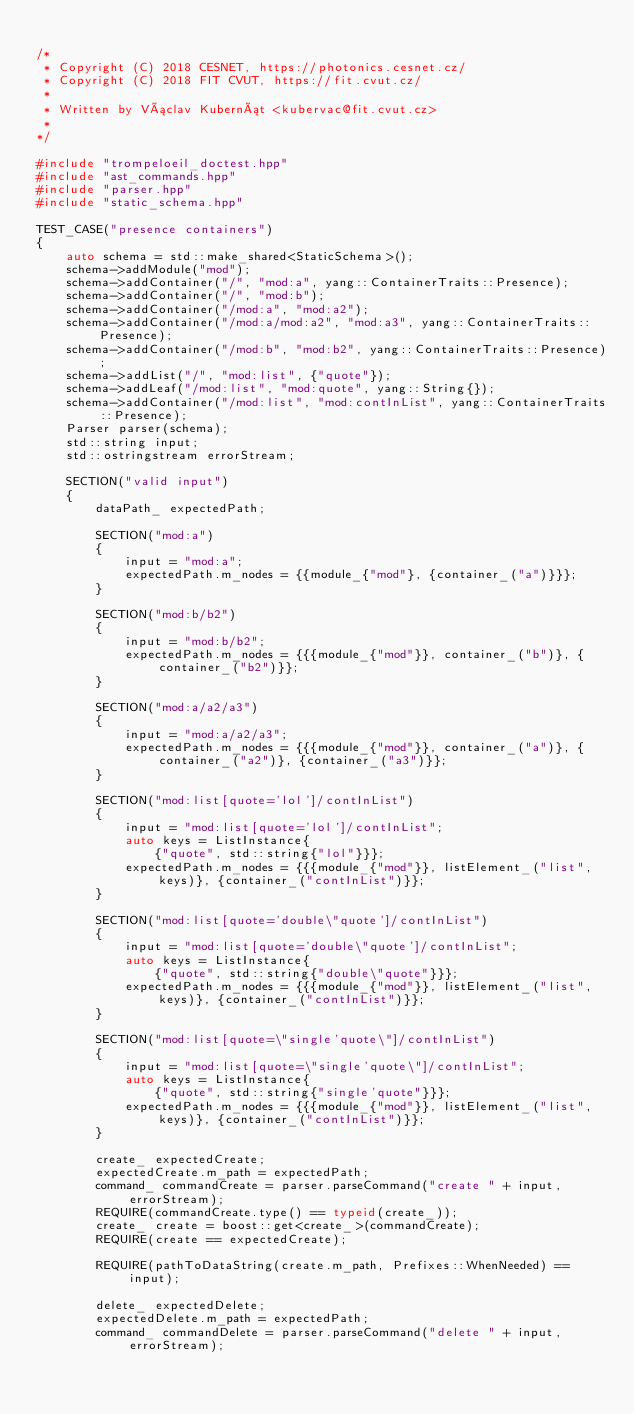Convert code to text. <code><loc_0><loc_0><loc_500><loc_500><_C++_>
/*
 * Copyright (C) 2018 CESNET, https://photonics.cesnet.cz/
 * Copyright (C) 2018 FIT CVUT, https://fit.cvut.cz/
 *
 * Written by Václav Kubernát <kubervac@fit.cvut.cz>
 *
*/

#include "trompeloeil_doctest.hpp"
#include "ast_commands.hpp"
#include "parser.hpp"
#include "static_schema.hpp"

TEST_CASE("presence containers")
{
    auto schema = std::make_shared<StaticSchema>();
    schema->addModule("mod");
    schema->addContainer("/", "mod:a", yang::ContainerTraits::Presence);
    schema->addContainer("/", "mod:b");
    schema->addContainer("/mod:a", "mod:a2");
    schema->addContainer("/mod:a/mod:a2", "mod:a3", yang::ContainerTraits::Presence);
    schema->addContainer("/mod:b", "mod:b2", yang::ContainerTraits::Presence);
    schema->addList("/", "mod:list", {"quote"});
    schema->addLeaf("/mod:list", "mod:quote", yang::String{});
    schema->addContainer("/mod:list", "mod:contInList", yang::ContainerTraits::Presence);
    Parser parser(schema);
    std::string input;
    std::ostringstream errorStream;

    SECTION("valid input")
    {
        dataPath_ expectedPath;

        SECTION("mod:a")
        {
            input = "mod:a";
            expectedPath.m_nodes = {{module_{"mod"}, {container_("a")}}};
        }

        SECTION("mod:b/b2")
        {
            input = "mod:b/b2";
            expectedPath.m_nodes = {{{module_{"mod"}}, container_("b")}, {container_("b2")}};
        }

        SECTION("mod:a/a2/a3")
        {
            input = "mod:a/a2/a3";
            expectedPath.m_nodes = {{{module_{"mod"}}, container_("a")}, {container_("a2")}, {container_("a3")}};
        }

        SECTION("mod:list[quote='lol']/contInList")
        {
            input = "mod:list[quote='lol']/contInList";
            auto keys = ListInstance{
                {"quote", std::string{"lol"}}};
            expectedPath.m_nodes = {{{module_{"mod"}}, listElement_("list", keys)}, {container_("contInList")}};
        }

        SECTION("mod:list[quote='double\"quote']/contInList")
        {
            input = "mod:list[quote='double\"quote']/contInList";
            auto keys = ListInstance{
                {"quote", std::string{"double\"quote"}}};
            expectedPath.m_nodes = {{{module_{"mod"}}, listElement_("list", keys)}, {container_("contInList")}};
        }

        SECTION("mod:list[quote=\"single'quote\"]/contInList")
        {
            input = "mod:list[quote=\"single'quote\"]/contInList";
            auto keys = ListInstance{
                {"quote", std::string{"single'quote"}}};
            expectedPath.m_nodes = {{{module_{"mod"}}, listElement_("list", keys)}, {container_("contInList")}};
        }

        create_ expectedCreate;
        expectedCreate.m_path = expectedPath;
        command_ commandCreate = parser.parseCommand("create " + input, errorStream);
        REQUIRE(commandCreate.type() == typeid(create_));
        create_ create = boost::get<create_>(commandCreate);
        REQUIRE(create == expectedCreate);

        REQUIRE(pathToDataString(create.m_path, Prefixes::WhenNeeded) == input);

        delete_ expectedDelete;
        expectedDelete.m_path = expectedPath;
        command_ commandDelete = parser.parseCommand("delete " + input, errorStream);</code> 